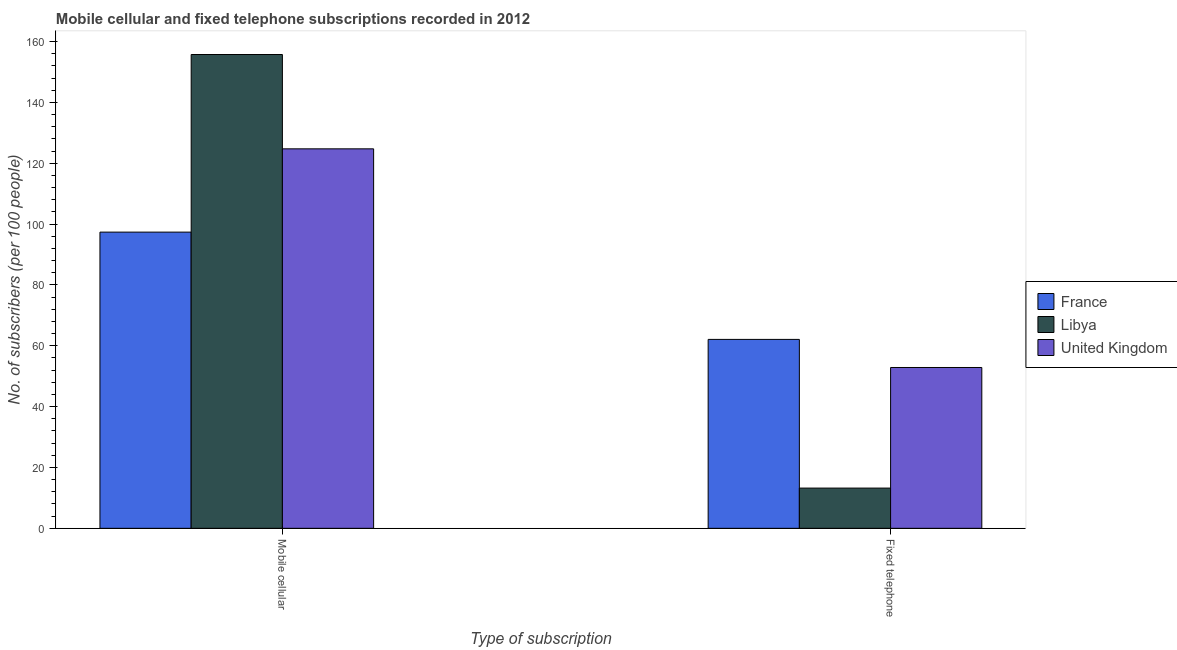What is the label of the 2nd group of bars from the left?
Make the answer very short. Fixed telephone. What is the number of fixed telephone subscribers in Libya?
Your response must be concise. 13.23. Across all countries, what is the maximum number of fixed telephone subscribers?
Your answer should be compact. 62.11. Across all countries, what is the minimum number of mobile cellular subscribers?
Your answer should be very brief. 97.38. What is the total number of mobile cellular subscribers in the graph?
Provide a short and direct response. 377.91. What is the difference between the number of fixed telephone subscribers in France and that in Libya?
Your answer should be compact. 48.88. What is the difference between the number of mobile cellular subscribers in France and the number of fixed telephone subscribers in Libya?
Your answer should be very brief. 84.15. What is the average number of fixed telephone subscribers per country?
Offer a very short reply. 42.74. What is the difference between the number of mobile cellular subscribers and number of fixed telephone subscribers in France?
Give a very brief answer. 35.27. What is the ratio of the number of mobile cellular subscribers in United Kingdom to that in France?
Provide a short and direct response. 1.28. Is the number of mobile cellular subscribers in Libya less than that in United Kingdom?
Offer a very short reply. No. What does the 3rd bar from the left in Mobile cellular represents?
Your answer should be very brief. United Kingdom. What does the 3rd bar from the right in Mobile cellular represents?
Provide a short and direct response. France. How many bars are there?
Provide a short and direct response. 6. What is the difference between two consecutive major ticks on the Y-axis?
Ensure brevity in your answer.  20. Does the graph contain grids?
Provide a succinct answer. No. Where does the legend appear in the graph?
Your response must be concise. Center right. How are the legend labels stacked?
Make the answer very short. Vertical. What is the title of the graph?
Provide a succinct answer. Mobile cellular and fixed telephone subscriptions recorded in 2012. What is the label or title of the X-axis?
Your response must be concise. Type of subscription. What is the label or title of the Y-axis?
Offer a very short reply. No. of subscribers (per 100 people). What is the No. of subscribers (per 100 people) of France in Mobile cellular?
Provide a short and direct response. 97.38. What is the No. of subscribers (per 100 people) of Libya in Mobile cellular?
Your answer should be very brief. 155.77. What is the No. of subscribers (per 100 people) of United Kingdom in Mobile cellular?
Your answer should be very brief. 124.76. What is the No. of subscribers (per 100 people) in France in Fixed telephone?
Provide a short and direct response. 62.11. What is the No. of subscribers (per 100 people) of Libya in Fixed telephone?
Ensure brevity in your answer.  13.23. What is the No. of subscribers (per 100 people) of United Kingdom in Fixed telephone?
Your answer should be very brief. 52.88. Across all Type of subscription, what is the maximum No. of subscribers (per 100 people) of France?
Provide a short and direct response. 97.38. Across all Type of subscription, what is the maximum No. of subscribers (per 100 people) of Libya?
Ensure brevity in your answer.  155.77. Across all Type of subscription, what is the maximum No. of subscribers (per 100 people) of United Kingdom?
Your response must be concise. 124.76. Across all Type of subscription, what is the minimum No. of subscribers (per 100 people) in France?
Offer a very short reply. 62.11. Across all Type of subscription, what is the minimum No. of subscribers (per 100 people) of Libya?
Give a very brief answer. 13.23. Across all Type of subscription, what is the minimum No. of subscribers (per 100 people) of United Kingdom?
Offer a terse response. 52.88. What is the total No. of subscribers (per 100 people) in France in the graph?
Provide a short and direct response. 159.49. What is the total No. of subscribers (per 100 people) in Libya in the graph?
Offer a very short reply. 168.99. What is the total No. of subscribers (per 100 people) in United Kingdom in the graph?
Your answer should be very brief. 177.64. What is the difference between the No. of subscribers (per 100 people) of France in Mobile cellular and that in Fixed telephone?
Give a very brief answer. 35.27. What is the difference between the No. of subscribers (per 100 people) in Libya in Mobile cellular and that in Fixed telephone?
Your answer should be very brief. 142.54. What is the difference between the No. of subscribers (per 100 people) in United Kingdom in Mobile cellular and that in Fixed telephone?
Your answer should be compact. 71.89. What is the difference between the No. of subscribers (per 100 people) of France in Mobile cellular and the No. of subscribers (per 100 people) of Libya in Fixed telephone?
Offer a very short reply. 84.15. What is the difference between the No. of subscribers (per 100 people) of France in Mobile cellular and the No. of subscribers (per 100 people) of United Kingdom in Fixed telephone?
Keep it short and to the point. 44.5. What is the difference between the No. of subscribers (per 100 people) of Libya in Mobile cellular and the No. of subscribers (per 100 people) of United Kingdom in Fixed telephone?
Make the answer very short. 102.89. What is the average No. of subscribers (per 100 people) in France per Type of subscription?
Your answer should be compact. 79.74. What is the average No. of subscribers (per 100 people) in Libya per Type of subscription?
Keep it short and to the point. 84.5. What is the average No. of subscribers (per 100 people) of United Kingdom per Type of subscription?
Your answer should be very brief. 88.82. What is the difference between the No. of subscribers (per 100 people) in France and No. of subscribers (per 100 people) in Libya in Mobile cellular?
Make the answer very short. -58.39. What is the difference between the No. of subscribers (per 100 people) of France and No. of subscribers (per 100 people) of United Kingdom in Mobile cellular?
Give a very brief answer. -27.38. What is the difference between the No. of subscribers (per 100 people) of Libya and No. of subscribers (per 100 people) of United Kingdom in Mobile cellular?
Provide a succinct answer. 31.01. What is the difference between the No. of subscribers (per 100 people) of France and No. of subscribers (per 100 people) of Libya in Fixed telephone?
Keep it short and to the point. 48.88. What is the difference between the No. of subscribers (per 100 people) of France and No. of subscribers (per 100 people) of United Kingdom in Fixed telephone?
Provide a succinct answer. 9.23. What is the difference between the No. of subscribers (per 100 people) in Libya and No. of subscribers (per 100 people) in United Kingdom in Fixed telephone?
Ensure brevity in your answer.  -39.65. What is the ratio of the No. of subscribers (per 100 people) in France in Mobile cellular to that in Fixed telephone?
Keep it short and to the point. 1.57. What is the ratio of the No. of subscribers (per 100 people) in Libya in Mobile cellular to that in Fixed telephone?
Your response must be concise. 11.78. What is the ratio of the No. of subscribers (per 100 people) of United Kingdom in Mobile cellular to that in Fixed telephone?
Provide a succinct answer. 2.36. What is the difference between the highest and the second highest No. of subscribers (per 100 people) of France?
Your response must be concise. 35.27. What is the difference between the highest and the second highest No. of subscribers (per 100 people) of Libya?
Keep it short and to the point. 142.54. What is the difference between the highest and the second highest No. of subscribers (per 100 people) of United Kingdom?
Your answer should be compact. 71.89. What is the difference between the highest and the lowest No. of subscribers (per 100 people) of France?
Your answer should be compact. 35.27. What is the difference between the highest and the lowest No. of subscribers (per 100 people) in Libya?
Provide a short and direct response. 142.54. What is the difference between the highest and the lowest No. of subscribers (per 100 people) of United Kingdom?
Your answer should be very brief. 71.89. 